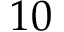<formula> <loc_0><loc_0><loc_500><loc_500>1 0</formula> 